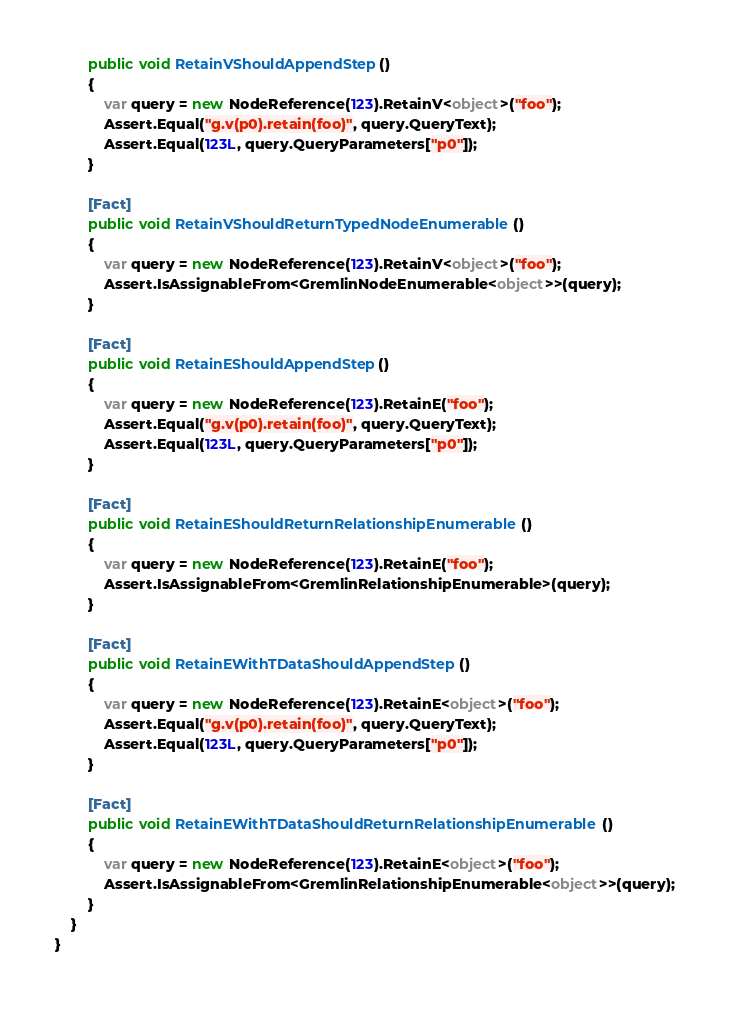Convert code to text. <code><loc_0><loc_0><loc_500><loc_500><_C#_>        public void RetainVShouldAppendStep()
        {
            var query = new NodeReference(123).RetainV<object>("foo");
            Assert.Equal("g.v(p0).retain(foo)", query.QueryText);
            Assert.Equal(123L, query.QueryParameters["p0"]);
        }

        [Fact]
        public void RetainVShouldReturnTypedNodeEnumerable()
        {
            var query = new NodeReference(123).RetainV<object>("foo");
            Assert.IsAssignableFrom<GremlinNodeEnumerable<object>>(query);
        }

        [Fact]
        public void RetainEShouldAppendStep()
        {
            var query = new NodeReference(123).RetainE("foo");
            Assert.Equal("g.v(p0).retain(foo)", query.QueryText);
            Assert.Equal(123L, query.QueryParameters["p0"]);
        }

        [Fact]
        public void RetainEShouldReturnRelationshipEnumerable()
        {
            var query = new NodeReference(123).RetainE("foo");
            Assert.IsAssignableFrom<GremlinRelationshipEnumerable>(query);
        }

        [Fact]
        public void RetainEWithTDataShouldAppendStep()
        {
            var query = new NodeReference(123).RetainE<object>("foo");
            Assert.Equal("g.v(p0).retain(foo)", query.QueryText);
            Assert.Equal(123L, query.QueryParameters["p0"]);
        }

        [Fact]
        public void RetainEWithTDataShouldReturnRelationshipEnumerable()
        {
            var query = new NodeReference(123).RetainE<object>("foo");
            Assert.IsAssignableFrom<GremlinRelationshipEnumerable<object>>(query);
        }
    }
}</code> 